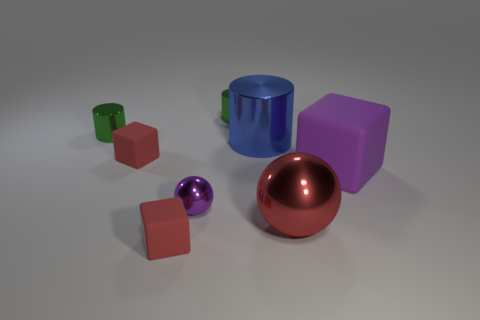Subtract all small cubes. How many cubes are left? 1 Add 2 small purple things. How many objects exist? 10 Subtract all red cubes. How many cubes are left? 1 Subtract all gray cylinders. How many red blocks are left? 2 Subtract all cylinders. How many objects are left? 5 Subtract all brown metal objects. Subtract all purple spheres. How many objects are left? 7 Add 1 red metal balls. How many red metal balls are left? 2 Add 4 metal objects. How many metal objects exist? 9 Subtract 0 blue blocks. How many objects are left? 8 Subtract 1 cylinders. How many cylinders are left? 2 